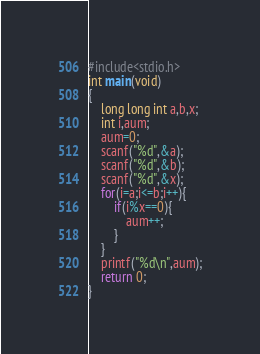<code> <loc_0><loc_0><loc_500><loc_500><_C++_>#include<stdio.h>
int main(void)
{
	long long int a,b,x;
	int i,aum;
	aum=0;
	scanf("%d",&a);
	scanf("%d",&b);
	scanf("%d",&x);
	for(i=a;i<=b;i++){
		if(i%x==0){
			aum++;
		}
	}
	printf("%d\n",aum);
	return 0;
}</code> 